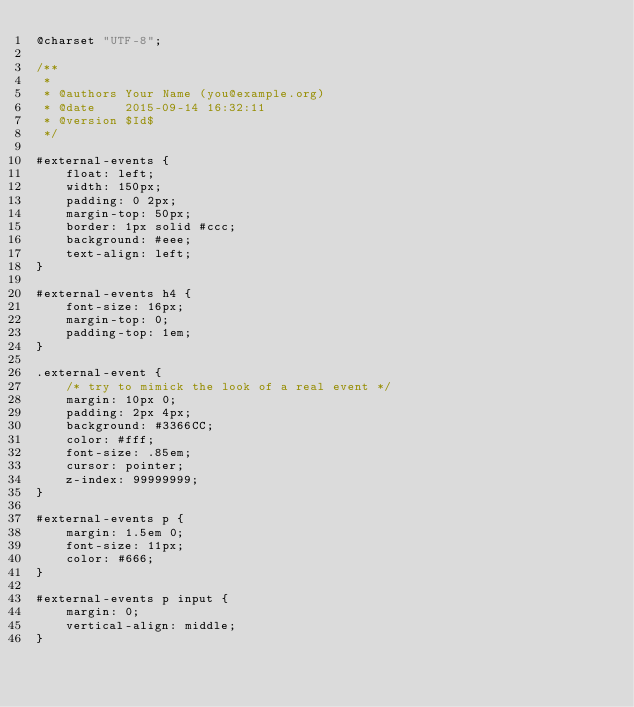Convert code to text. <code><loc_0><loc_0><loc_500><loc_500><_CSS_>@charset "UTF-8";

/**
 * 
 * @authors Your Name (you@example.org)
 * @date    2015-09-14 16:32:11
 * @version $Id$
 */

#external-events {
    float: left;
    width: 150px;
    padding: 0 2px;
    margin-top: 50px;
    border: 1px solid #ccc;
    background: #eee;
    text-align: left;
}

#external-events h4 {
    font-size: 16px;
    margin-top: 0;
    padding-top: 1em;
}

.external-event {
    /* try to mimick the look of a real event */
    margin: 10px 0;
    padding: 2px 4px;
    background: #3366CC;
    color: #fff;
    font-size: .85em;
    cursor: pointer;
    z-index: 99999999;
}

#external-events p {
    margin: 1.5em 0;
    font-size: 11px;
    color: #666;
}

#external-events p input {
    margin: 0;
    vertical-align: middle;
}
</code> 